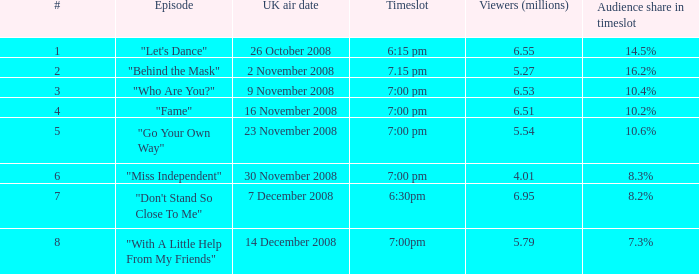Name the timeslot for 6.51 viewers 7:00 pm. 